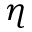<formula> <loc_0><loc_0><loc_500><loc_500>\eta</formula> 